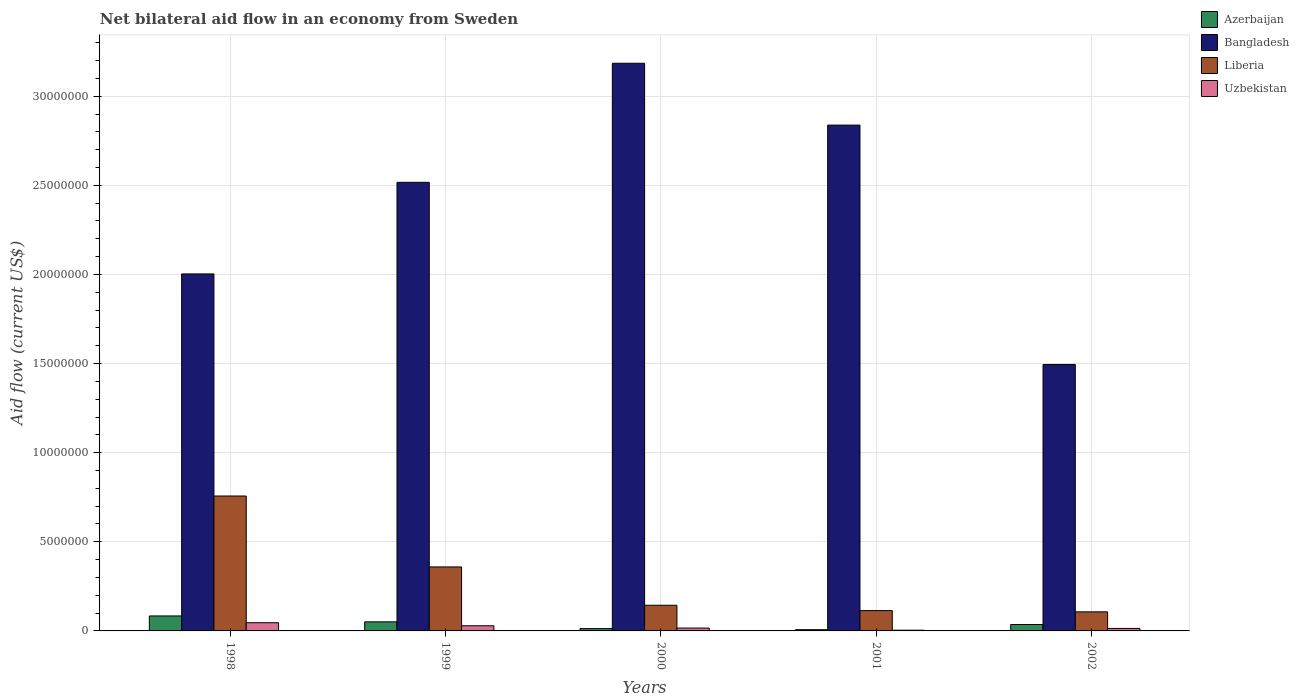How many groups of bars are there?
Offer a terse response. 5. Are the number of bars per tick equal to the number of legend labels?
Your answer should be compact. Yes. Are the number of bars on each tick of the X-axis equal?
Offer a terse response. Yes. How many bars are there on the 1st tick from the left?
Ensure brevity in your answer.  4. How many bars are there on the 4th tick from the right?
Provide a short and direct response. 4. What is the label of the 4th group of bars from the left?
Provide a succinct answer. 2001. What is the net bilateral aid flow in Uzbekistan in 2002?
Keep it short and to the point. 1.40e+05. Across all years, what is the maximum net bilateral aid flow in Uzbekistan?
Provide a succinct answer. 4.60e+05. Across all years, what is the minimum net bilateral aid flow in Uzbekistan?
Offer a terse response. 4.00e+04. In which year was the net bilateral aid flow in Uzbekistan minimum?
Your answer should be compact. 2001. What is the total net bilateral aid flow in Azerbaijan in the graph?
Offer a very short reply. 1.91e+06. What is the difference between the net bilateral aid flow in Azerbaijan in 2000 and that in 2001?
Offer a very short reply. 6.00e+04. What is the difference between the net bilateral aid flow in Bangladesh in 1998 and the net bilateral aid flow in Azerbaijan in 2001?
Make the answer very short. 2.00e+07. What is the average net bilateral aid flow in Uzbekistan per year?
Make the answer very short. 2.18e+05. In the year 1999, what is the difference between the net bilateral aid flow in Uzbekistan and net bilateral aid flow in Azerbaijan?
Offer a terse response. -2.20e+05. What is the ratio of the net bilateral aid flow in Liberia in 1999 to that in 2000?
Your response must be concise. 2.49. What is the difference between the highest and the lowest net bilateral aid flow in Uzbekistan?
Offer a very short reply. 4.20e+05. What does the 1st bar from the left in 1998 represents?
Your answer should be very brief. Azerbaijan. What does the 4th bar from the right in 1998 represents?
Your answer should be compact. Azerbaijan. Is it the case that in every year, the sum of the net bilateral aid flow in Uzbekistan and net bilateral aid flow in Liberia is greater than the net bilateral aid flow in Azerbaijan?
Your response must be concise. Yes. How many years are there in the graph?
Your response must be concise. 5. Does the graph contain any zero values?
Provide a succinct answer. No. What is the title of the graph?
Provide a succinct answer. Net bilateral aid flow in an economy from Sweden. Does "Thailand" appear as one of the legend labels in the graph?
Your answer should be compact. No. What is the Aid flow (current US$) of Azerbaijan in 1998?
Make the answer very short. 8.40e+05. What is the Aid flow (current US$) in Bangladesh in 1998?
Offer a terse response. 2.00e+07. What is the Aid flow (current US$) of Liberia in 1998?
Keep it short and to the point. 7.57e+06. What is the Aid flow (current US$) in Azerbaijan in 1999?
Ensure brevity in your answer.  5.10e+05. What is the Aid flow (current US$) in Bangladesh in 1999?
Provide a short and direct response. 2.52e+07. What is the Aid flow (current US$) in Liberia in 1999?
Keep it short and to the point. 3.59e+06. What is the Aid flow (current US$) of Uzbekistan in 1999?
Make the answer very short. 2.90e+05. What is the Aid flow (current US$) of Bangladesh in 2000?
Give a very brief answer. 3.18e+07. What is the Aid flow (current US$) in Liberia in 2000?
Keep it short and to the point. 1.44e+06. What is the Aid flow (current US$) of Azerbaijan in 2001?
Your answer should be very brief. 7.00e+04. What is the Aid flow (current US$) in Bangladesh in 2001?
Offer a terse response. 2.84e+07. What is the Aid flow (current US$) of Liberia in 2001?
Provide a succinct answer. 1.14e+06. What is the Aid flow (current US$) in Bangladesh in 2002?
Your response must be concise. 1.50e+07. What is the Aid flow (current US$) in Liberia in 2002?
Make the answer very short. 1.07e+06. Across all years, what is the maximum Aid flow (current US$) of Azerbaijan?
Ensure brevity in your answer.  8.40e+05. Across all years, what is the maximum Aid flow (current US$) of Bangladesh?
Your answer should be compact. 3.18e+07. Across all years, what is the maximum Aid flow (current US$) in Liberia?
Ensure brevity in your answer.  7.57e+06. Across all years, what is the minimum Aid flow (current US$) in Bangladesh?
Provide a succinct answer. 1.50e+07. Across all years, what is the minimum Aid flow (current US$) of Liberia?
Make the answer very short. 1.07e+06. What is the total Aid flow (current US$) of Azerbaijan in the graph?
Your answer should be compact. 1.91e+06. What is the total Aid flow (current US$) of Bangladesh in the graph?
Make the answer very short. 1.20e+08. What is the total Aid flow (current US$) in Liberia in the graph?
Provide a short and direct response. 1.48e+07. What is the total Aid flow (current US$) of Uzbekistan in the graph?
Make the answer very short. 1.09e+06. What is the difference between the Aid flow (current US$) of Bangladesh in 1998 and that in 1999?
Keep it short and to the point. -5.14e+06. What is the difference between the Aid flow (current US$) in Liberia in 1998 and that in 1999?
Make the answer very short. 3.98e+06. What is the difference between the Aid flow (current US$) of Azerbaijan in 1998 and that in 2000?
Give a very brief answer. 7.10e+05. What is the difference between the Aid flow (current US$) of Bangladesh in 1998 and that in 2000?
Give a very brief answer. -1.18e+07. What is the difference between the Aid flow (current US$) of Liberia in 1998 and that in 2000?
Offer a terse response. 6.13e+06. What is the difference between the Aid flow (current US$) in Uzbekistan in 1998 and that in 2000?
Your answer should be very brief. 3.00e+05. What is the difference between the Aid flow (current US$) of Azerbaijan in 1998 and that in 2001?
Provide a short and direct response. 7.70e+05. What is the difference between the Aid flow (current US$) of Bangladesh in 1998 and that in 2001?
Offer a very short reply. -8.35e+06. What is the difference between the Aid flow (current US$) of Liberia in 1998 and that in 2001?
Your response must be concise. 6.43e+06. What is the difference between the Aid flow (current US$) of Uzbekistan in 1998 and that in 2001?
Your answer should be very brief. 4.20e+05. What is the difference between the Aid flow (current US$) of Azerbaijan in 1998 and that in 2002?
Provide a succinct answer. 4.80e+05. What is the difference between the Aid flow (current US$) of Bangladesh in 1998 and that in 2002?
Make the answer very short. 5.08e+06. What is the difference between the Aid flow (current US$) in Liberia in 1998 and that in 2002?
Provide a short and direct response. 6.50e+06. What is the difference between the Aid flow (current US$) in Azerbaijan in 1999 and that in 2000?
Provide a short and direct response. 3.80e+05. What is the difference between the Aid flow (current US$) of Bangladesh in 1999 and that in 2000?
Ensure brevity in your answer.  -6.68e+06. What is the difference between the Aid flow (current US$) of Liberia in 1999 and that in 2000?
Provide a succinct answer. 2.15e+06. What is the difference between the Aid flow (current US$) in Uzbekistan in 1999 and that in 2000?
Your response must be concise. 1.30e+05. What is the difference between the Aid flow (current US$) in Bangladesh in 1999 and that in 2001?
Offer a very short reply. -3.21e+06. What is the difference between the Aid flow (current US$) of Liberia in 1999 and that in 2001?
Ensure brevity in your answer.  2.45e+06. What is the difference between the Aid flow (current US$) in Uzbekistan in 1999 and that in 2001?
Provide a short and direct response. 2.50e+05. What is the difference between the Aid flow (current US$) of Bangladesh in 1999 and that in 2002?
Provide a succinct answer. 1.02e+07. What is the difference between the Aid flow (current US$) in Liberia in 1999 and that in 2002?
Provide a short and direct response. 2.52e+06. What is the difference between the Aid flow (current US$) in Uzbekistan in 1999 and that in 2002?
Make the answer very short. 1.50e+05. What is the difference between the Aid flow (current US$) in Azerbaijan in 2000 and that in 2001?
Give a very brief answer. 6.00e+04. What is the difference between the Aid flow (current US$) of Bangladesh in 2000 and that in 2001?
Your answer should be compact. 3.47e+06. What is the difference between the Aid flow (current US$) in Liberia in 2000 and that in 2001?
Ensure brevity in your answer.  3.00e+05. What is the difference between the Aid flow (current US$) in Azerbaijan in 2000 and that in 2002?
Your answer should be compact. -2.30e+05. What is the difference between the Aid flow (current US$) in Bangladesh in 2000 and that in 2002?
Provide a succinct answer. 1.69e+07. What is the difference between the Aid flow (current US$) of Uzbekistan in 2000 and that in 2002?
Provide a succinct answer. 2.00e+04. What is the difference between the Aid flow (current US$) in Azerbaijan in 2001 and that in 2002?
Ensure brevity in your answer.  -2.90e+05. What is the difference between the Aid flow (current US$) of Bangladesh in 2001 and that in 2002?
Provide a succinct answer. 1.34e+07. What is the difference between the Aid flow (current US$) in Liberia in 2001 and that in 2002?
Keep it short and to the point. 7.00e+04. What is the difference between the Aid flow (current US$) in Azerbaijan in 1998 and the Aid flow (current US$) in Bangladesh in 1999?
Offer a very short reply. -2.43e+07. What is the difference between the Aid flow (current US$) of Azerbaijan in 1998 and the Aid flow (current US$) of Liberia in 1999?
Make the answer very short. -2.75e+06. What is the difference between the Aid flow (current US$) in Bangladesh in 1998 and the Aid flow (current US$) in Liberia in 1999?
Provide a succinct answer. 1.64e+07. What is the difference between the Aid flow (current US$) in Bangladesh in 1998 and the Aid flow (current US$) in Uzbekistan in 1999?
Offer a terse response. 1.97e+07. What is the difference between the Aid flow (current US$) in Liberia in 1998 and the Aid flow (current US$) in Uzbekistan in 1999?
Your answer should be very brief. 7.28e+06. What is the difference between the Aid flow (current US$) of Azerbaijan in 1998 and the Aid flow (current US$) of Bangladesh in 2000?
Ensure brevity in your answer.  -3.10e+07. What is the difference between the Aid flow (current US$) in Azerbaijan in 1998 and the Aid flow (current US$) in Liberia in 2000?
Give a very brief answer. -6.00e+05. What is the difference between the Aid flow (current US$) in Azerbaijan in 1998 and the Aid flow (current US$) in Uzbekistan in 2000?
Your answer should be compact. 6.80e+05. What is the difference between the Aid flow (current US$) in Bangladesh in 1998 and the Aid flow (current US$) in Liberia in 2000?
Offer a very short reply. 1.86e+07. What is the difference between the Aid flow (current US$) of Bangladesh in 1998 and the Aid flow (current US$) of Uzbekistan in 2000?
Your answer should be very brief. 1.99e+07. What is the difference between the Aid flow (current US$) in Liberia in 1998 and the Aid flow (current US$) in Uzbekistan in 2000?
Provide a short and direct response. 7.41e+06. What is the difference between the Aid flow (current US$) of Azerbaijan in 1998 and the Aid flow (current US$) of Bangladesh in 2001?
Give a very brief answer. -2.75e+07. What is the difference between the Aid flow (current US$) of Azerbaijan in 1998 and the Aid flow (current US$) of Liberia in 2001?
Offer a very short reply. -3.00e+05. What is the difference between the Aid flow (current US$) of Azerbaijan in 1998 and the Aid flow (current US$) of Uzbekistan in 2001?
Provide a short and direct response. 8.00e+05. What is the difference between the Aid flow (current US$) in Bangladesh in 1998 and the Aid flow (current US$) in Liberia in 2001?
Ensure brevity in your answer.  1.89e+07. What is the difference between the Aid flow (current US$) of Bangladesh in 1998 and the Aid flow (current US$) of Uzbekistan in 2001?
Provide a succinct answer. 2.00e+07. What is the difference between the Aid flow (current US$) in Liberia in 1998 and the Aid flow (current US$) in Uzbekistan in 2001?
Offer a terse response. 7.53e+06. What is the difference between the Aid flow (current US$) of Azerbaijan in 1998 and the Aid flow (current US$) of Bangladesh in 2002?
Give a very brief answer. -1.41e+07. What is the difference between the Aid flow (current US$) of Azerbaijan in 1998 and the Aid flow (current US$) of Liberia in 2002?
Offer a terse response. -2.30e+05. What is the difference between the Aid flow (current US$) of Azerbaijan in 1998 and the Aid flow (current US$) of Uzbekistan in 2002?
Provide a succinct answer. 7.00e+05. What is the difference between the Aid flow (current US$) of Bangladesh in 1998 and the Aid flow (current US$) of Liberia in 2002?
Keep it short and to the point. 1.90e+07. What is the difference between the Aid flow (current US$) in Bangladesh in 1998 and the Aid flow (current US$) in Uzbekistan in 2002?
Offer a very short reply. 1.99e+07. What is the difference between the Aid flow (current US$) in Liberia in 1998 and the Aid flow (current US$) in Uzbekistan in 2002?
Ensure brevity in your answer.  7.43e+06. What is the difference between the Aid flow (current US$) in Azerbaijan in 1999 and the Aid flow (current US$) in Bangladesh in 2000?
Provide a succinct answer. -3.13e+07. What is the difference between the Aid flow (current US$) of Azerbaijan in 1999 and the Aid flow (current US$) of Liberia in 2000?
Give a very brief answer. -9.30e+05. What is the difference between the Aid flow (current US$) of Azerbaijan in 1999 and the Aid flow (current US$) of Uzbekistan in 2000?
Provide a succinct answer. 3.50e+05. What is the difference between the Aid flow (current US$) of Bangladesh in 1999 and the Aid flow (current US$) of Liberia in 2000?
Give a very brief answer. 2.37e+07. What is the difference between the Aid flow (current US$) of Bangladesh in 1999 and the Aid flow (current US$) of Uzbekistan in 2000?
Your answer should be compact. 2.50e+07. What is the difference between the Aid flow (current US$) in Liberia in 1999 and the Aid flow (current US$) in Uzbekistan in 2000?
Provide a succinct answer. 3.43e+06. What is the difference between the Aid flow (current US$) of Azerbaijan in 1999 and the Aid flow (current US$) of Bangladesh in 2001?
Give a very brief answer. -2.79e+07. What is the difference between the Aid flow (current US$) in Azerbaijan in 1999 and the Aid flow (current US$) in Liberia in 2001?
Make the answer very short. -6.30e+05. What is the difference between the Aid flow (current US$) in Azerbaijan in 1999 and the Aid flow (current US$) in Uzbekistan in 2001?
Provide a succinct answer. 4.70e+05. What is the difference between the Aid flow (current US$) of Bangladesh in 1999 and the Aid flow (current US$) of Liberia in 2001?
Your answer should be compact. 2.40e+07. What is the difference between the Aid flow (current US$) in Bangladesh in 1999 and the Aid flow (current US$) in Uzbekistan in 2001?
Give a very brief answer. 2.51e+07. What is the difference between the Aid flow (current US$) of Liberia in 1999 and the Aid flow (current US$) of Uzbekistan in 2001?
Provide a succinct answer. 3.55e+06. What is the difference between the Aid flow (current US$) of Azerbaijan in 1999 and the Aid flow (current US$) of Bangladesh in 2002?
Your answer should be compact. -1.44e+07. What is the difference between the Aid flow (current US$) in Azerbaijan in 1999 and the Aid flow (current US$) in Liberia in 2002?
Your response must be concise. -5.60e+05. What is the difference between the Aid flow (current US$) in Azerbaijan in 1999 and the Aid flow (current US$) in Uzbekistan in 2002?
Make the answer very short. 3.70e+05. What is the difference between the Aid flow (current US$) of Bangladesh in 1999 and the Aid flow (current US$) of Liberia in 2002?
Make the answer very short. 2.41e+07. What is the difference between the Aid flow (current US$) in Bangladesh in 1999 and the Aid flow (current US$) in Uzbekistan in 2002?
Give a very brief answer. 2.50e+07. What is the difference between the Aid flow (current US$) of Liberia in 1999 and the Aid flow (current US$) of Uzbekistan in 2002?
Your answer should be very brief. 3.45e+06. What is the difference between the Aid flow (current US$) of Azerbaijan in 2000 and the Aid flow (current US$) of Bangladesh in 2001?
Your answer should be very brief. -2.82e+07. What is the difference between the Aid flow (current US$) of Azerbaijan in 2000 and the Aid flow (current US$) of Liberia in 2001?
Offer a terse response. -1.01e+06. What is the difference between the Aid flow (current US$) of Bangladesh in 2000 and the Aid flow (current US$) of Liberia in 2001?
Offer a very short reply. 3.07e+07. What is the difference between the Aid flow (current US$) of Bangladesh in 2000 and the Aid flow (current US$) of Uzbekistan in 2001?
Offer a very short reply. 3.18e+07. What is the difference between the Aid flow (current US$) in Liberia in 2000 and the Aid flow (current US$) in Uzbekistan in 2001?
Your answer should be compact. 1.40e+06. What is the difference between the Aid flow (current US$) in Azerbaijan in 2000 and the Aid flow (current US$) in Bangladesh in 2002?
Keep it short and to the point. -1.48e+07. What is the difference between the Aid flow (current US$) in Azerbaijan in 2000 and the Aid flow (current US$) in Liberia in 2002?
Your response must be concise. -9.40e+05. What is the difference between the Aid flow (current US$) in Bangladesh in 2000 and the Aid flow (current US$) in Liberia in 2002?
Keep it short and to the point. 3.08e+07. What is the difference between the Aid flow (current US$) in Bangladesh in 2000 and the Aid flow (current US$) in Uzbekistan in 2002?
Offer a terse response. 3.17e+07. What is the difference between the Aid flow (current US$) of Liberia in 2000 and the Aid flow (current US$) of Uzbekistan in 2002?
Provide a succinct answer. 1.30e+06. What is the difference between the Aid flow (current US$) of Azerbaijan in 2001 and the Aid flow (current US$) of Bangladesh in 2002?
Ensure brevity in your answer.  -1.49e+07. What is the difference between the Aid flow (current US$) in Azerbaijan in 2001 and the Aid flow (current US$) in Uzbekistan in 2002?
Give a very brief answer. -7.00e+04. What is the difference between the Aid flow (current US$) of Bangladesh in 2001 and the Aid flow (current US$) of Liberia in 2002?
Ensure brevity in your answer.  2.73e+07. What is the difference between the Aid flow (current US$) of Bangladesh in 2001 and the Aid flow (current US$) of Uzbekistan in 2002?
Your answer should be very brief. 2.82e+07. What is the difference between the Aid flow (current US$) in Liberia in 2001 and the Aid flow (current US$) in Uzbekistan in 2002?
Your answer should be compact. 1.00e+06. What is the average Aid flow (current US$) of Azerbaijan per year?
Your answer should be very brief. 3.82e+05. What is the average Aid flow (current US$) in Bangladesh per year?
Your answer should be very brief. 2.41e+07. What is the average Aid flow (current US$) in Liberia per year?
Provide a succinct answer. 2.96e+06. What is the average Aid flow (current US$) of Uzbekistan per year?
Offer a terse response. 2.18e+05. In the year 1998, what is the difference between the Aid flow (current US$) of Azerbaijan and Aid flow (current US$) of Bangladesh?
Offer a very short reply. -1.92e+07. In the year 1998, what is the difference between the Aid flow (current US$) of Azerbaijan and Aid flow (current US$) of Liberia?
Your response must be concise. -6.73e+06. In the year 1998, what is the difference between the Aid flow (current US$) in Bangladesh and Aid flow (current US$) in Liberia?
Keep it short and to the point. 1.25e+07. In the year 1998, what is the difference between the Aid flow (current US$) of Bangladesh and Aid flow (current US$) of Uzbekistan?
Your answer should be very brief. 1.96e+07. In the year 1998, what is the difference between the Aid flow (current US$) in Liberia and Aid flow (current US$) in Uzbekistan?
Your answer should be very brief. 7.11e+06. In the year 1999, what is the difference between the Aid flow (current US$) in Azerbaijan and Aid flow (current US$) in Bangladesh?
Offer a very short reply. -2.47e+07. In the year 1999, what is the difference between the Aid flow (current US$) in Azerbaijan and Aid flow (current US$) in Liberia?
Ensure brevity in your answer.  -3.08e+06. In the year 1999, what is the difference between the Aid flow (current US$) of Bangladesh and Aid flow (current US$) of Liberia?
Keep it short and to the point. 2.16e+07. In the year 1999, what is the difference between the Aid flow (current US$) of Bangladesh and Aid flow (current US$) of Uzbekistan?
Your answer should be compact. 2.49e+07. In the year 1999, what is the difference between the Aid flow (current US$) of Liberia and Aid flow (current US$) of Uzbekistan?
Offer a terse response. 3.30e+06. In the year 2000, what is the difference between the Aid flow (current US$) in Azerbaijan and Aid flow (current US$) in Bangladesh?
Offer a terse response. -3.17e+07. In the year 2000, what is the difference between the Aid flow (current US$) in Azerbaijan and Aid flow (current US$) in Liberia?
Give a very brief answer. -1.31e+06. In the year 2000, what is the difference between the Aid flow (current US$) in Bangladesh and Aid flow (current US$) in Liberia?
Your response must be concise. 3.04e+07. In the year 2000, what is the difference between the Aid flow (current US$) of Bangladesh and Aid flow (current US$) of Uzbekistan?
Give a very brief answer. 3.17e+07. In the year 2000, what is the difference between the Aid flow (current US$) of Liberia and Aid flow (current US$) of Uzbekistan?
Your answer should be very brief. 1.28e+06. In the year 2001, what is the difference between the Aid flow (current US$) of Azerbaijan and Aid flow (current US$) of Bangladesh?
Give a very brief answer. -2.83e+07. In the year 2001, what is the difference between the Aid flow (current US$) in Azerbaijan and Aid flow (current US$) in Liberia?
Keep it short and to the point. -1.07e+06. In the year 2001, what is the difference between the Aid flow (current US$) of Azerbaijan and Aid flow (current US$) of Uzbekistan?
Ensure brevity in your answer.  3.00e+04. In the year 2001, what is the difference between the Aid flow (current US$) in Bangladesh and Aid flow (current US$) in Liberia?
Keep it short and to the point. 2.72e+07. In the year 2001, what is the difference between the Aid flow (current US$) in Bangladesh and Aid flow (current US$) in Uzbekistan?
Offer a very short reply. 2.83e+07. In the year 2001, what is the difference between the Aid flow (current US$) in Liberia and Aid flow (current US$) in Uzbekistan?
Provide a short and direct response. 1.10e+06. In the year 2002, what is the difference between the Aid flow (current US$) in Azerbaijan and Aid flow (current US$) in Bangladesh?
Provide a short and direct response. -1.46e+07. In the year 2002, what is the difference between the Aid flow (current US$) in Azerbaijan and Aid flow (current US$) in Liberia?
Offer a very short reply. -7.10e+05. In the year 2002, what is the difference between the Aid flow (current US$) in Azerbaijan and Aid flow (current US$) in Uzbekistan?
Keep it short and to the point. 2.20e+05. In the year 2002, what is the difference between the Aid flow (current US$) of Bangladesh and Aid flow (current US$) of Liberia?
Keep it short and to the point. 1.39e+07. In the year 2002, what is the difference between the Aid flow (current US$) in Bangladesh and Aid flow (current US$) in Uzbekistan?
Offer a very short reply. 1.48e+07. In the year 2002, what is the difference between the Aid flow (current US$) in Liberia and Aid flow (current US$) in Uzbekistan?
Provide a succinct answer. 9.30e+05. What is the ratio of the Aid flow (current US$) of Azerbaijan in 1998 to that in 1999?
Give a very brief answer. 1.65. What is the ratio of the Aid flow (current US$) of Bangladesh in 1998 to that in 1999?
Make the answer very short. 0.8. What is the ratio of the Aid flow (current US$) of Liberia in 1998 to that in 1999?
Your answer should be compact. 2.11. What is the ratio of the Aid flow (current US$) of Uzbekistan in 1998 to that in 1999?
Offer a very short reply. 1.59. What is the ratio of the Aid flow (current US$) of Azerbaijan in 1998 to that in 2000?
Provide a short and direct response. 6.46. What is the ratio of the Aid flow (current US$) of Bangladesh in 1998 to that in 2000?
Give a very brief answer. 0.63. What is the ratio of the Aid flow (current US$) in Liberia in 1998 to that in 2000?
Offer a very short reply. 5.26. What is the ratio of the Aid flow (current US$) of Uzbekistan in 1998 to that in 2000?
Keep it short and to the point. 2.88. What is the ratio of the Aid flow (current US$) of Azerbaijan in 1998 to that in 2001?
Ensure brevity in your answer.  12. What is the ratio of the Aid flow (current US$) in Bangladesh in 1998 to that in 2001?
Provide a short and direct response. 0.71. What is the ratio of the Aid flow (current US$) of Liberia in 1998 to that in 2001?
Ensure brevity in your answer.  6.64. What is the ratio of the Aid flow (current US$) in Uzbekistan in 1998 to that in 2001?
Your answer should be very brief. 11.5. What is the ratio of the Aid flow (current US$) in Azerbaijan in 1998 to that in 2002?
Your answer should be very brief. 2.33. What is the ratio of the Aid flow (current US$) in Bangladesh in 1998 to that in 2002?
Offer a terse response. 1.34. What is the ratio of the Aid flow (current US$) in Liberia in 1998 to that in 2002?
Provide a succinct answer. 7.07. What is the ratio of the Aid flow (current US$) in Uzbekistan in 1998 to that in 2002?
Offer a terse response. 3.29. What is the ratio of the Aid flow (current US$) of Azerbaijan in 1999 to that in 2000?
Keep it short and to the point. 3.92. What is the ratio of the Aid flow (current US$) of Bangladesh in 1999 to that in 2000?
Ensure brevity in your answer.  0.79. What is the ratio of the Aid flow (current US$) in Liberia in 1999 to that in 2000?
Your answer should be compact. 2.49. What is the ratio of the Aid flow (current US$) of Uzbekistan in 1999 to that in 2000?
Give a very brief answer. 1.81. What is the ratio of the Aid flow (current US$) in Azerbaijan in 1999 to that in 2001?
Your response must be concise. 7.29. What is the ratio of the Aid flow (current US$) of Bangladesh in 1999 to that in 2001?
Your answer should be very brief. 0.89. What is the ratio of the Aid flow (current US$) in Liberia in 1999 to that in 2001?
Provide a succinct answer. 3.15. What is the ratio of the Aid flow (current US$) in Uzbekistan in 1999 to that in 2001?
Give a very brief answer. 7.25. What is the ratio of the Aid flow (current US$) of Azerbaijan in 1999 to that in 2002?
Make the answer very short. 1.42. What is the ratio of the Aid flow (current US$) in Bangladesh in 1999 to that in 2002?
Ensure brevity in your answer.  1.68. What is the ratio of the Aid flow (current US$) of Liberia in 1999 to that in 2002?
Give a very brief answer. 3.36. What is the ratio of the Aid flow (current US$) of Uzbekistan in 1999 to that in 2002?
Give a very brief answer. 2.07. What is the ratio of the Aid flow (current US$) of Azerbaijan in 2000 to that in 2001?
Make the answer very short. 1.86. What is the ratio of the Aid flow (current US$) in Bangladesh in 2000 to that in 2001?
Give a very brief answer. 1.12. What is the ratio of the Aid flow (current US$) in Liberia in 2000 to that in 2001?
Offer a terse response. 1.26. What is the ratio of the Aid flow (current US$) of Uzbekistan in 2000 to that in 2001?
Offer a very short reply. 4. What is the ratio of the Aid flow (current US$) in Azerbaijan in 2000 to that in 2002?
Your response must be concise. 0.36. What is the ratio of the Aid flow (current US$) of Bangladesh in 2000 to that in 2002?
Provide a succinct answer. 2.13. What is the ratio of the Aid flow (current US$) in Liberia in 2000 to that in 2002?
Your answer should be very brief. 1.35. What is the ratio of the Aid flow (current US$) in Azerbaijan in 2001 to that in 2002?
Ensure brevity in your answer.  0.19. What is the ratio of the Aid flow (current US$) in Bangladesh in 2001 to that in 2002?
Give a very brief answer. 1.9. What is the ratio of the Aid flow (current US$) of Liberia in 2001 to that in 2002?
Your answer should be compact. 1.07. What is the ratio of the Aid flow (current US$) of Uzbekistan in 2001 to that in 2002?
Ensure brevity in your answer.  0.29. What is the difference between the highest and the second highest Aid flow (current US$) in Bangladesh?
Ensure brevity in your answer.  3.47e+06. What is the difference between the highest and the second highest Aid flow (current US$) of Liberia?
Provide a succinct answer. 3.98e+06. What is the difference between the highest and the second highest Aid flow (current US$) of Uzbekistan?
Make the answer very short. 1.70e+05. What is the difference between the highest and the lowest Aid flow (current US$) in Azerbaijan?
Your response must be concise. 7.70e+05. What is the difference between the highest and the lowest Aid flow (current US$) of Bangladesh?
Your answer should be very brief. 1.69e+07. What is the difference between the highest and the lowest Aid flow (current US$) of Liberia?
Your answer should be compact. 6.50e+06. What is the difference between the highest and the lowest Aid flow (current US$) in Uzbekistan?
Your answer should be very brief. 4.20e+05. 